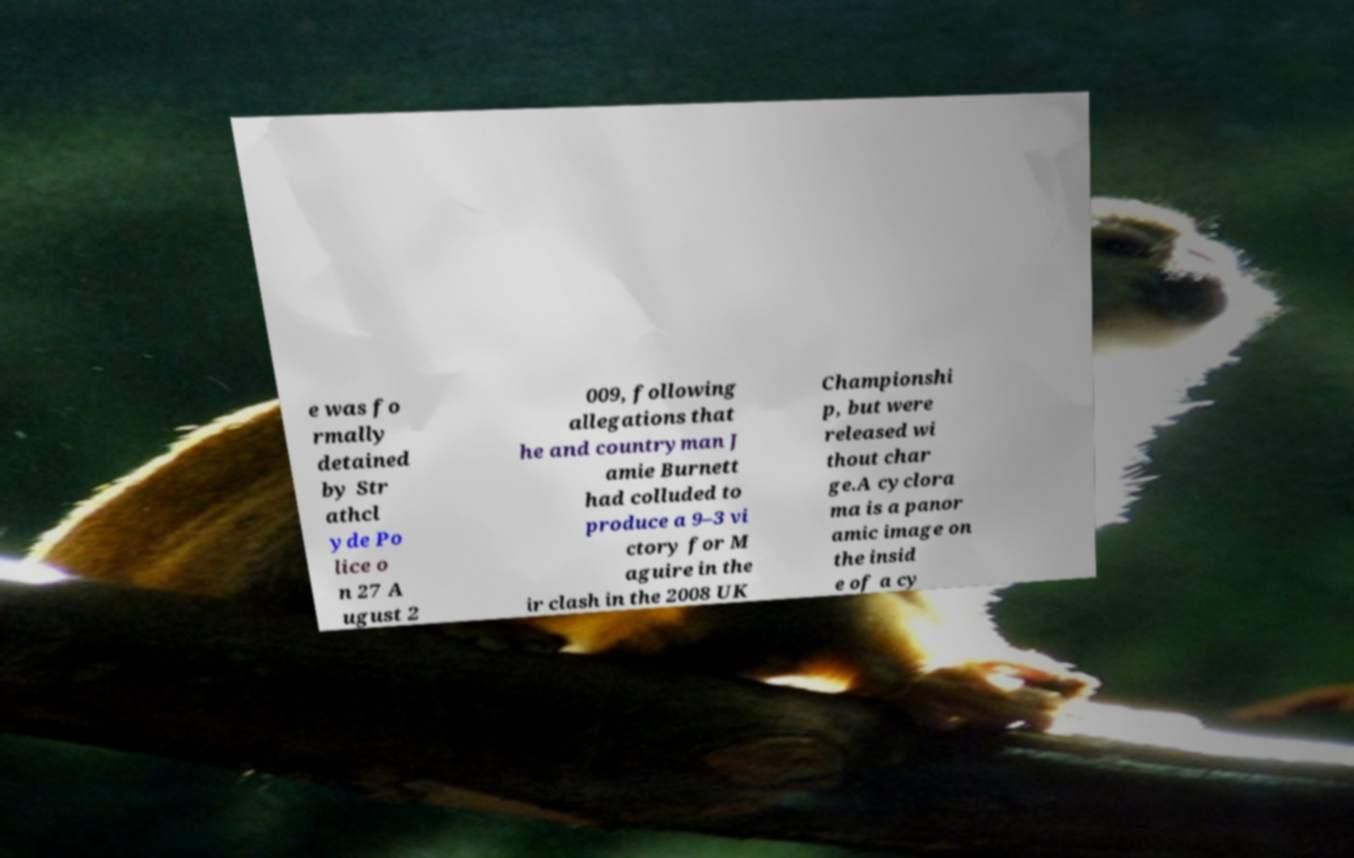Can you read and provide the text displayed in the image?This photo seems to have some interesting text. Can you extract and type it out for me? e was fo rmally detained by Str athcl yde Po lice o n 27 A ugust 2 009, following allegations that he and countryman J amie Burnett had colluded to produce a 9–3 vi ctory for M aguire in the ir clash in the 2008 UK Championshi p, but were released wi thout char ge.A cyclora ma is a panor amic image on the insid e of a cy 